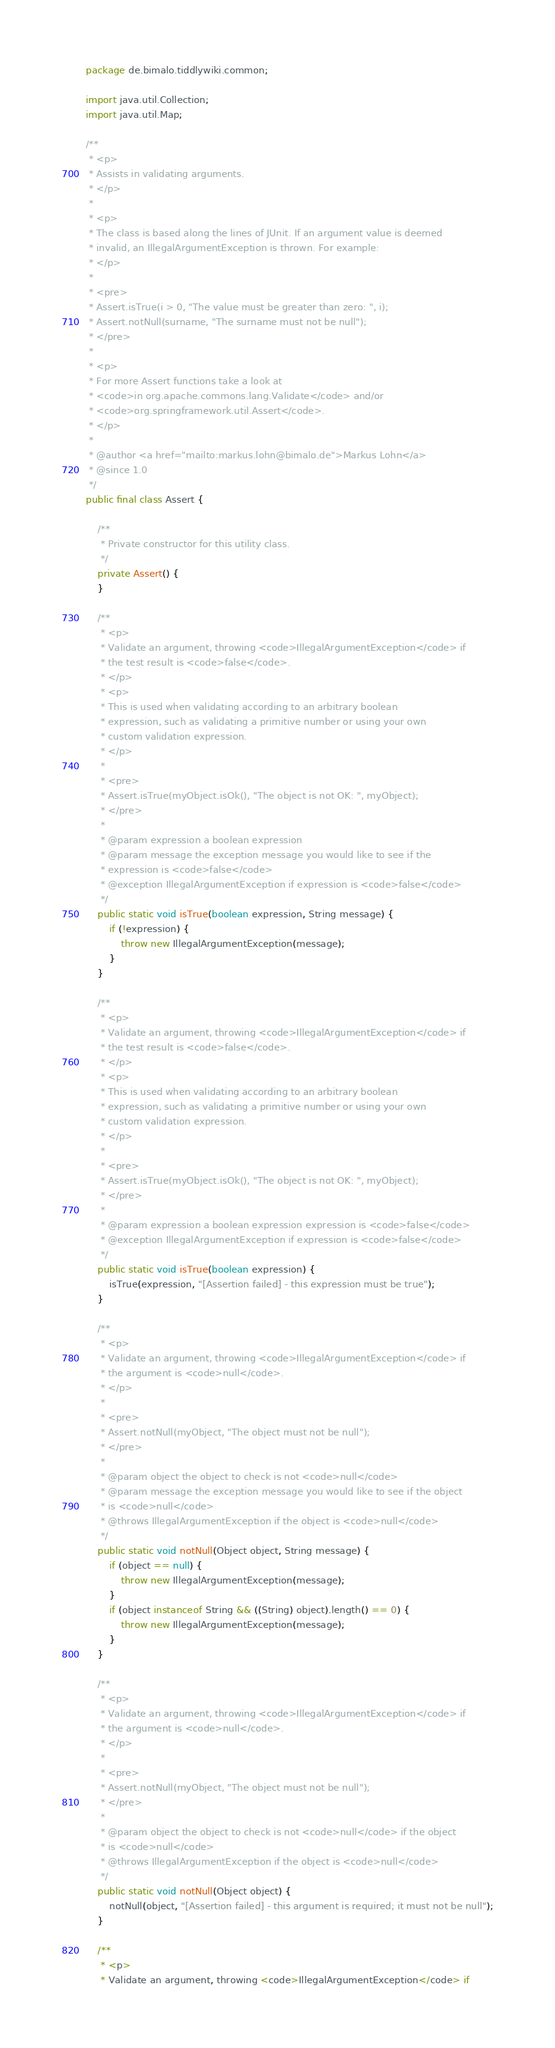Convert code to text. <code><loc_0><loc_0><loc_500><loc_500><_Java_>package de.bimalo.tiddlywiki.common;

import java.util.Collection;
import java.util.Map;

/**
 * <p>
 * Assists in validating arguments.
 * </p>
 *
 * <p>
 * The class is based along the lines of JUnit. If an argument value is deemed
 * invalid, an IllegalArgumentException is thrown. For example:
 * </p>
 *
 * <pre>
 * Assert.isTrue(i > 0, "The value must be greater than zero: ", i);
 * Assert.notNull(surname, "The surname must not be null");
 * </pre>
 *
 * <p>
 * For more Assert functions take a look at
 * <code>in org.apache.commons.lang.Validate</code> and/or
 * <code>org.springframework.util.Assert</code>.
 * </p>
 *
 * @author <a href="mailto:markus.lohn@bimalo.de">Markus Lohn</a>
 * @since 1.0
 */
public final class Assert {

    /**
     * Private constructor for this utility class.
     */
    private Assert() {
    }

    /**
     * <p>
     * Validate an argument, throwing <code>IllegalArgumentException</code> if
     * the test result is <code>false</code>.
     * </p>
     * <p>
     * This is used when validating according to an arbitrary boolean
     * expression, such as validating a primitive number or using your own
     * custom validation expression.
     * </p>
     *
     * <pre>
     * Assert.isTrue(myObject.isOk(), "The object is not OK: ", myObject);
     * </pre>
     *
     * @param expression a boolean expression
     * @param message the exception message you would like to see if the
     * expression is <code>false</code>
     * @exception IllegalArgumentException if expression is <code>false</code>
     */
    public static void isTrue(boolean expression, String message) {
        if (!expression) {
            throw new IllegalArgumentException(message);
        }
    }

    /**
     * <p>
     * Validate an argument, throwing <code>IllegalArgumentException</code> if
     * the test result is <code>false</code>.
     * </p>
     * <p>
     * This is used when validating according to an arbitrary boolean
     * expression, such as validating a primitive number or using your own
     * custom validation expression.
     * </p>
     *
     * <pre>
     * Assert.isTrue(myObject.isOk(), "The object is not OK: ", myObject);
     * </pre>
     *
     * @param expression a boolean expression expression is <code>false</code>
     * @exception IllegalArgumentException if expression is <code>false</code>
     */
    public static void isTrue(boolean expression) {
        isTrue(expression, "[Assertion failed] - this expression must be true");
    }

    /**
     * <p>
     * Validate an argument, throwing <code>IllegalArgumentException</code> if
     * the argument is <code>null</code>.
     * </p>
     *
     * <pre>
     * Assert.notNull(myObject, "The object must not be null");
     * </pre>
     *
     * @param object the object to check is not <code>null</code>
     * @param message the exception message you would like to see if the object
     * is <code>null</code>
     * @throws IllegalArgumentException if the object is <code>null</code>
     */
    public static void notNull(Object object, String message) {
        if (object == null) {
            throw new IllegalArgumentException(message);
        }
        if (object instanceof String && ((String) object).length() == 0) {
            throw new IllegalArgumentException(message);
        }
    }

    /**
     * <p>
     * Validate an argument, throwing <code>IllegalArgumentException</code> if
     * the argument is <code>null</code>.
     * </p>
     *
     * <pre>
     * Assert.notNull(myObject, "The object must not be null");
     * </pre>
     *
     * @param object the object to check is not <code>null</code> if the object
     * is <code>null</code>
     * @throws IllegalArgumentException if the object is <code>null</code>
     */
    public static void notNull(Object object) {
        notNull(object, "[Assertion failed] - this argument is required; it must not be null");
    }

    /**
     * <p>
     * Validate an argument, throwing <code>IllegalArgumentException</code> if</code> 